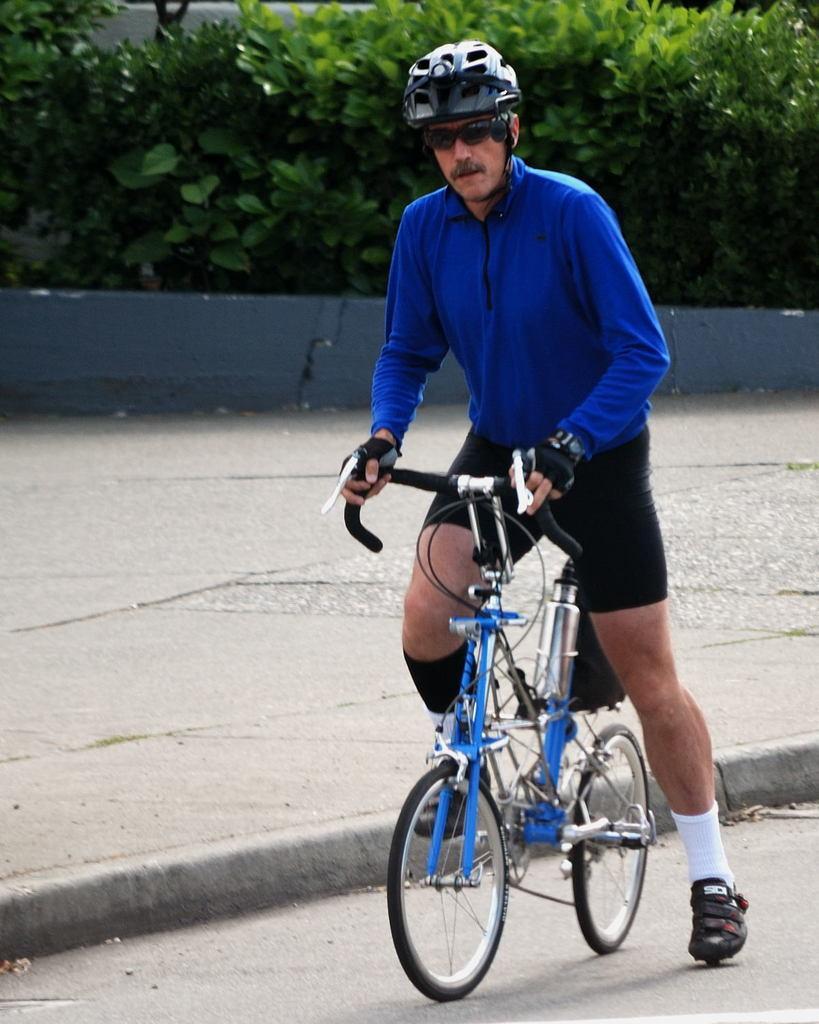Can you describe this image briefly? In this image in the center there is a man on the bicycle. In the background there are plants and there is a wall. 